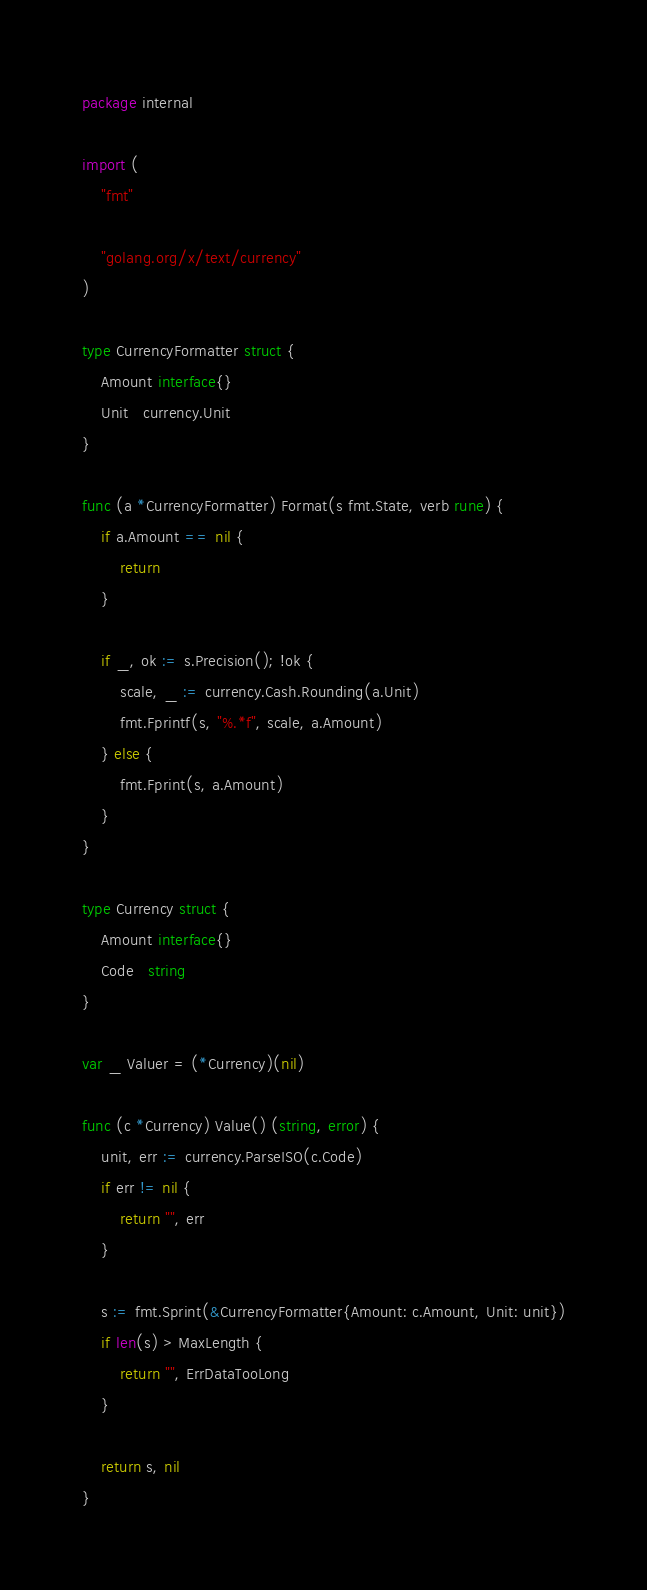<code> <loc_0><loc_0><loc_500><loc_500><_Go_>package internal

import (
	"fmt"

	"golang.org/x/text/currency"
)

type CurrencyFormatter struct {
	Amount interface{}
	Unit   currency.Unit
}

func (a *CurrencyFormatter) Format(s fmt.State, verb rune) {
	if a.Amount == nil {
		return
	}

	if _, ok := s.Precision(); !ok {
		scale, _ := currency.Cash.Rounding(a.Unit)
		fmt.Fprintf(s, "%.*f", scale, a.Amount)
	} else {
		fmt.Fprint(s, a.Amount)
	}
}

type Currency struct {
	Amount interface{}
	Code   string
}

var _ Valuer = (*Currency)(nil)

func (c *Currency) Value() (string, error) {
	unit, err := currency.ParseISO(c.Code)
	if err != nil {
		return "", err
	}

	s := fmt.Sprint(&CurrencyFormatter{Amount: c.Amount, Unit: unit})
	if len(s) > MaxLength {
		return "", ErrDataTooLong
	}

	return s, nil
}
</code> 